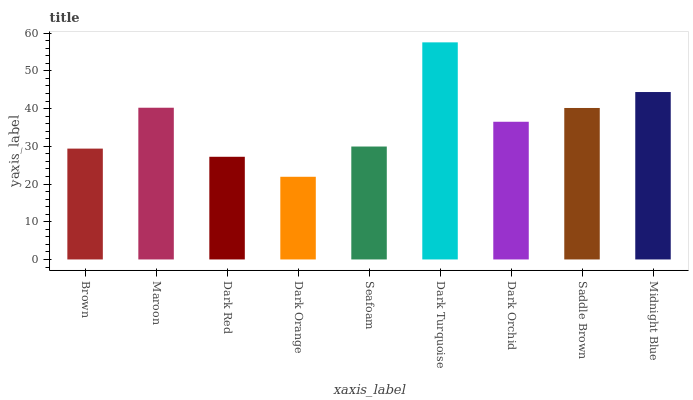Is Dark Orange the minimum?
Answer yes or no. Yes. Is Dark Turquoise the maximum?
Answer yes or no. Yes. Is Maroon the minimum?
Answer yes or no. No. Is Maroon the maximum?
Answer yes or no. No. Is Maroon greater than Brown?
Answer yes or no. Yes. Is Brown less than Maroon?
Answer yes or no. Yes. Is Brown greater than Maroon?
Answer yes or no. No. Is Maroon less than Brown?
Answer yes or no. No. Is Dark Orchid the high median?
Answer yes or no. Yes. Is Dark Orchid the low median?
Answer yes or no. Yes. Is Dark Orange the high median?
Answer yes or no. No. Is Seafoam the low median?
Answer yes or no. No. 